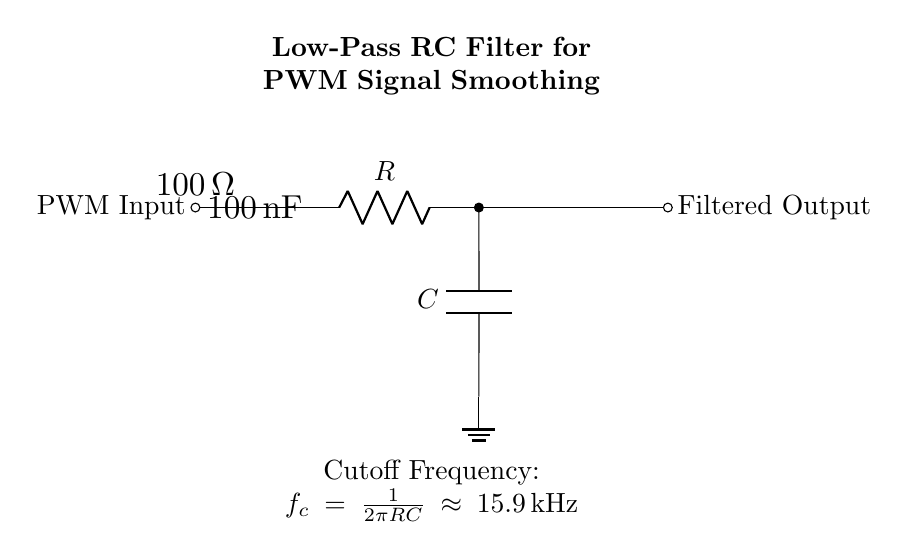What is the value of the resistor in the filter? The circuit diagram indicates that the resistor has a labeled value of one hundred ohms.
Answer: 100 ohm What type of filter is represented by this circuit? The circuit consists of a resistor and capacitor arranged to allow low-frequency signals to pass while attenuating high-frequency signals, characteristic of a low-pass filter.
Answer: Low-pass filter What is the capacitance value used in the circuit? The diagram clearly shows that the capacitor is labeled with a value of one hundred nanofarads, denoting its capacitance.
Answer: 100 nanofarad What frequency does this filter cut off at? Calculating the cutoff frequency using the formula provides: \( f_c = \frac{1}{2\pi RC} \), substituting the values \( R = 100 \) and \( C = 100\,\text{nF} \) gives approximately 15.9 kHz.
Answer: 15.9 kilohertz What is the purpose of the capacitor in this circuit? The capacitor is used to smooth out voltage variations by charging and discharging, thereby filtering out noise from the PWM signal.
Answer: Smoothing PWM signals What does PWM stand for in the context of this circuit? The term PWM represents pulse width modulation, which is a technique used to encode information in the width of the pulses in a pulse-train.
Answer: Pulse width modulation Where is the output labeled in the circuit? The output of the filter is indicated at the right side of the circuit layout, specifically labeled as "Filtered Output."
Answer: Filtered Output 